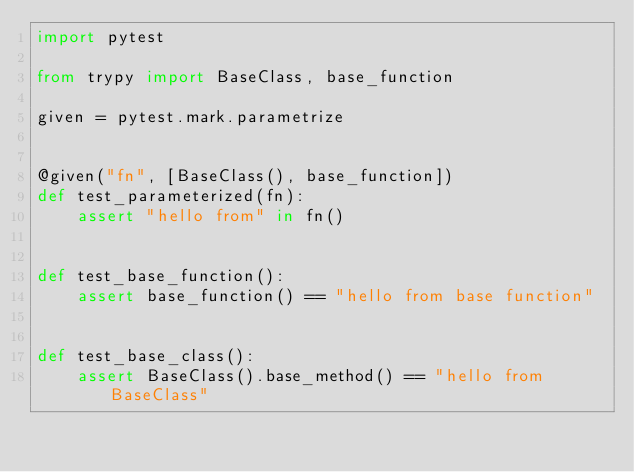Convert code to text. <code><loc_0><loc_0><loc_500><loc_500><_Python_>import pytest

from trypy import BaseClass, base_function

given = pytest.mark.parametrize


@given("fn", [BaseClass(), base_function])
def test_parameterized(fn):
    assert "hello from" in fn()


def test_base_function():
    assert base_function() == "hello from base function"


def test_base_class():
    assert BaseClass().base_method() == "hello from BaseClass"
</code> 